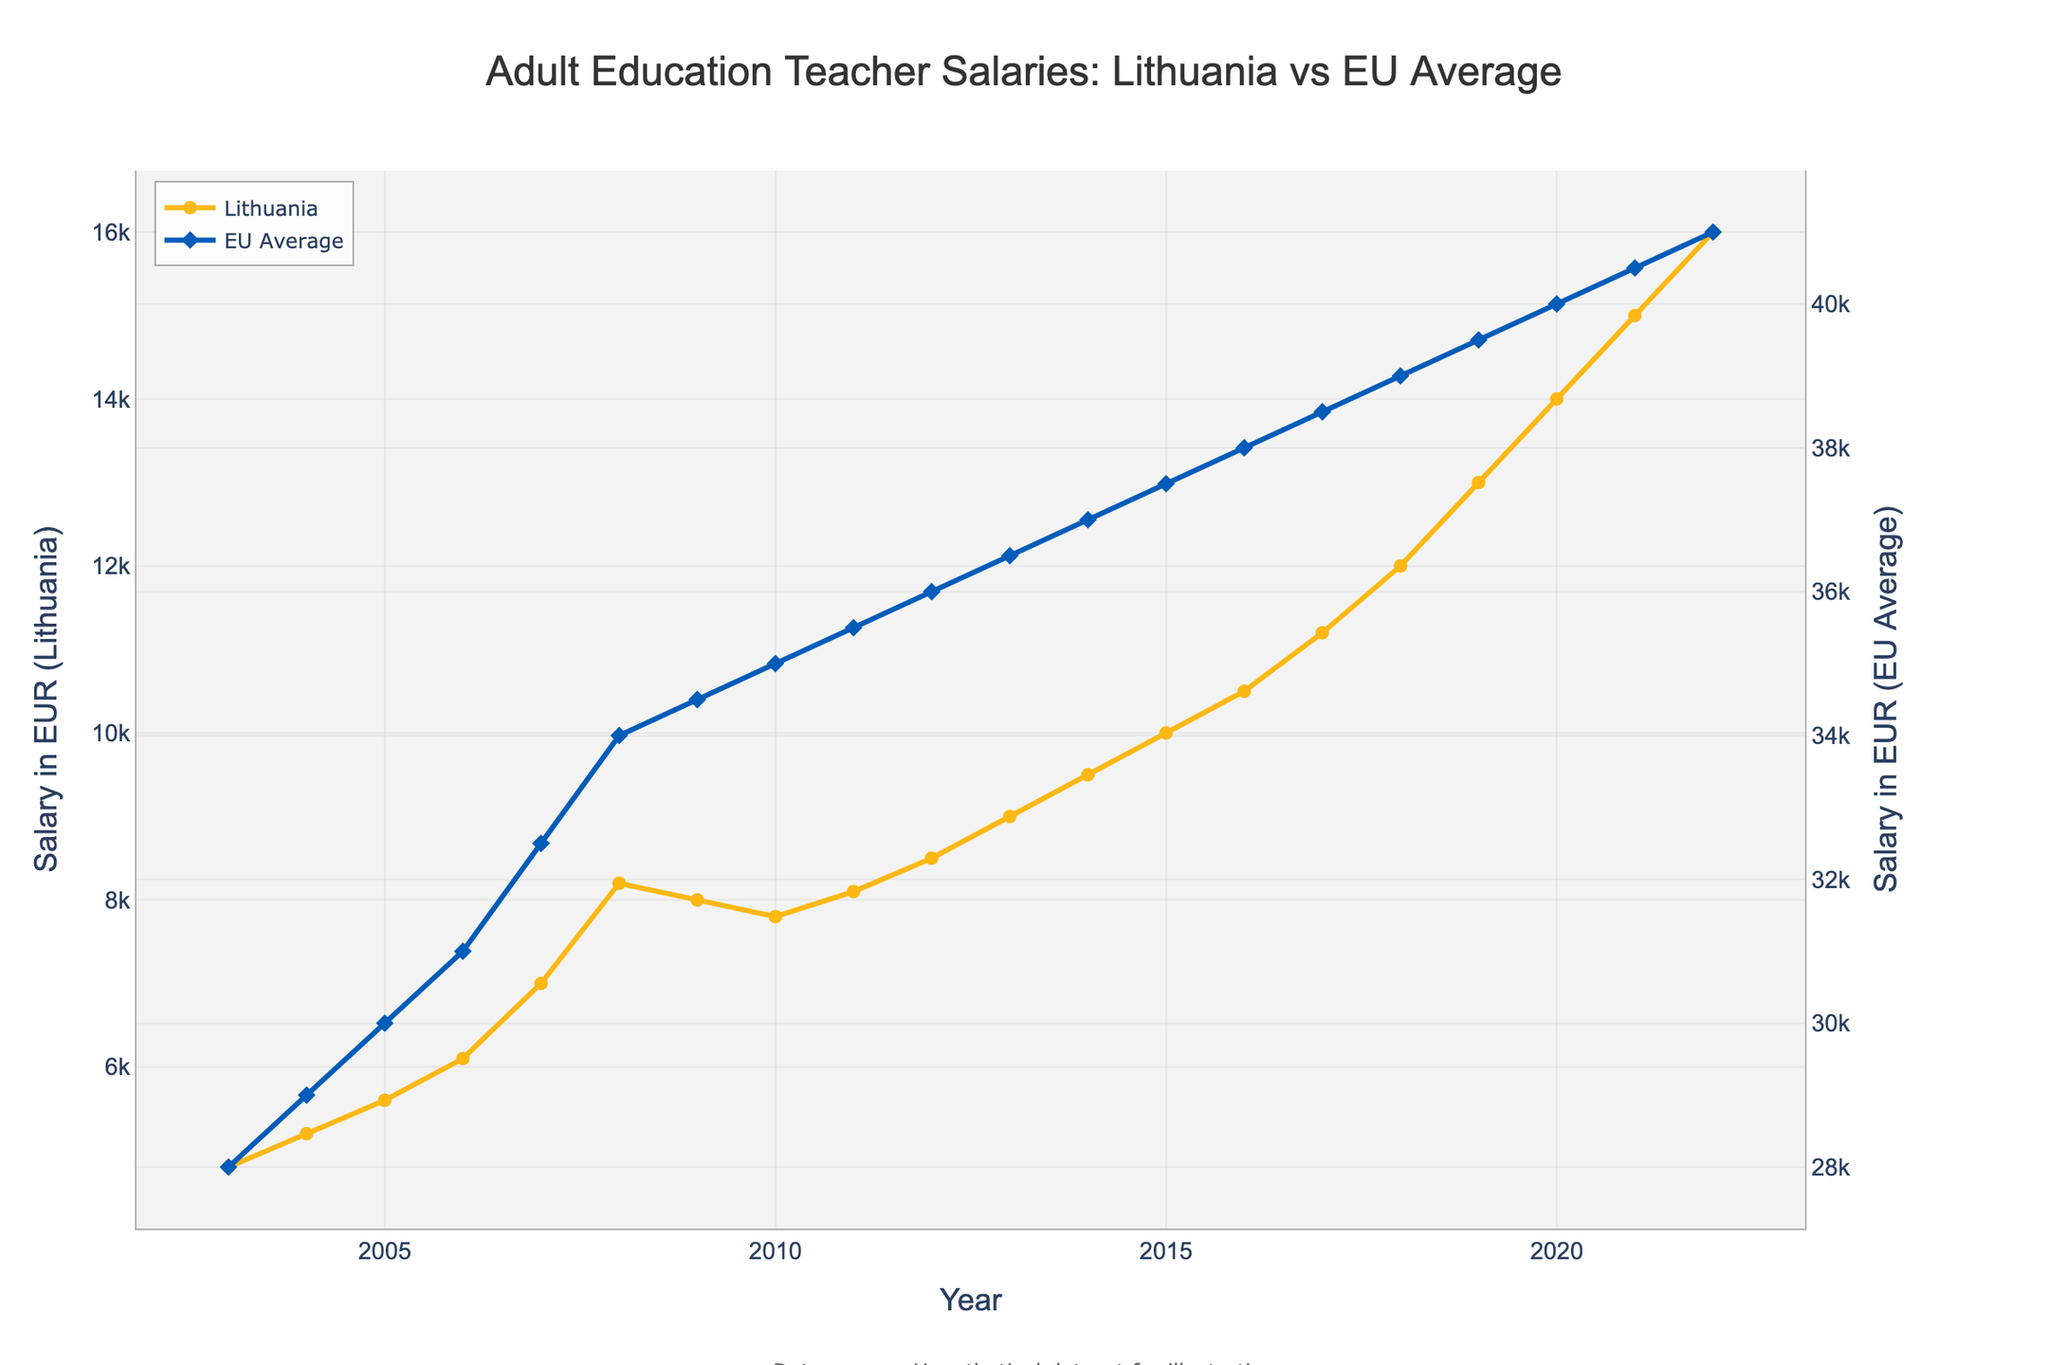Which year did the salaries of Lithuanian adult education teachers start showing significant growth compared to previous years? By observing the trend lines for Lithuanian teachers, there was a notable jump from 2006 to 2007. The salary increased from 6100 EUR to 7000 EUR, marking a significant growth compared to previous increments.
Answer: 2007 How does the slope of the Lithuanian salary trend compare to the EU average salary trend? By analyzing the steepness of both lines, the Lithuanian salary trend shows a steeper slope, particularly in the years from 2015 to 2022, indicating faster growth compared to the relatively steadier and gradual slope of the EU average trend.
Answer: Lithuanian trend is steeper In which years did the Lithuanian salaries decrease or stagnate? From the visual inspection of the Lithuanian salary line, there is a notable drop in 2009 and a slight decrease in 2010. Additionally, in 2011, the salary remained almost the same as the previous year.
Answer: 2009, 2010, 2011 What is the difference in salary between Lithuanian teachers and the EU average in 2022? The Lithuanian salary in 2022 is 16000 EUR and the EU average is 41000 EUR. The difference is 41000 - 16000 = 25000 EUR.
Answer: 25000 EUR How many times higher is the EU average salary than the Lithuanian salary in 2003? In 2003, the EU average salary is 28000 EUR and the Lithuanian salary is 4800 EUR. Dividing the EU average by the Lithuanian salary gives 28000 / 4800 = 5.83.
Answer: 5.83 times higher Which year had the smallest gap between Lithuanian and EU average salaries? Observing the chart, the smallest gap appears in the early years. Specifically, in 2003, the gap is 28000 - 4800 = 23200 EUR, which is the smallest compared to the following years.
Answer: 2003 By how much did the Lithuanian salary increase between 2010 and 2020? The Lithuanian salary in 2010 was 7800 EUR and in 2020 it was 14000 EUR. The increase is 14000 - 7800 = 6200 EUR.
Answer: 6200 EUR How does the color used for the Lithuanian salary trend compare with the EU average salary trend? The chart uses a yellow line with circle markers for the Lithuanian salary trend and a blue line with diamond markers for the EU average salary trend.
Answer: Yellow with circle markers vs. Blue with diamond markers What is the annual growth rate of Lithuanian salaries from 2013 to 2014? The salary in 2013 is 9000 EUR and in 2014 it is 9500 EUR. The growth is 9500 - 9000 = 500 EUR. The growth rate is (500 / 9000) * 100 ≈ 5.56%.
Answer: 5.56% 